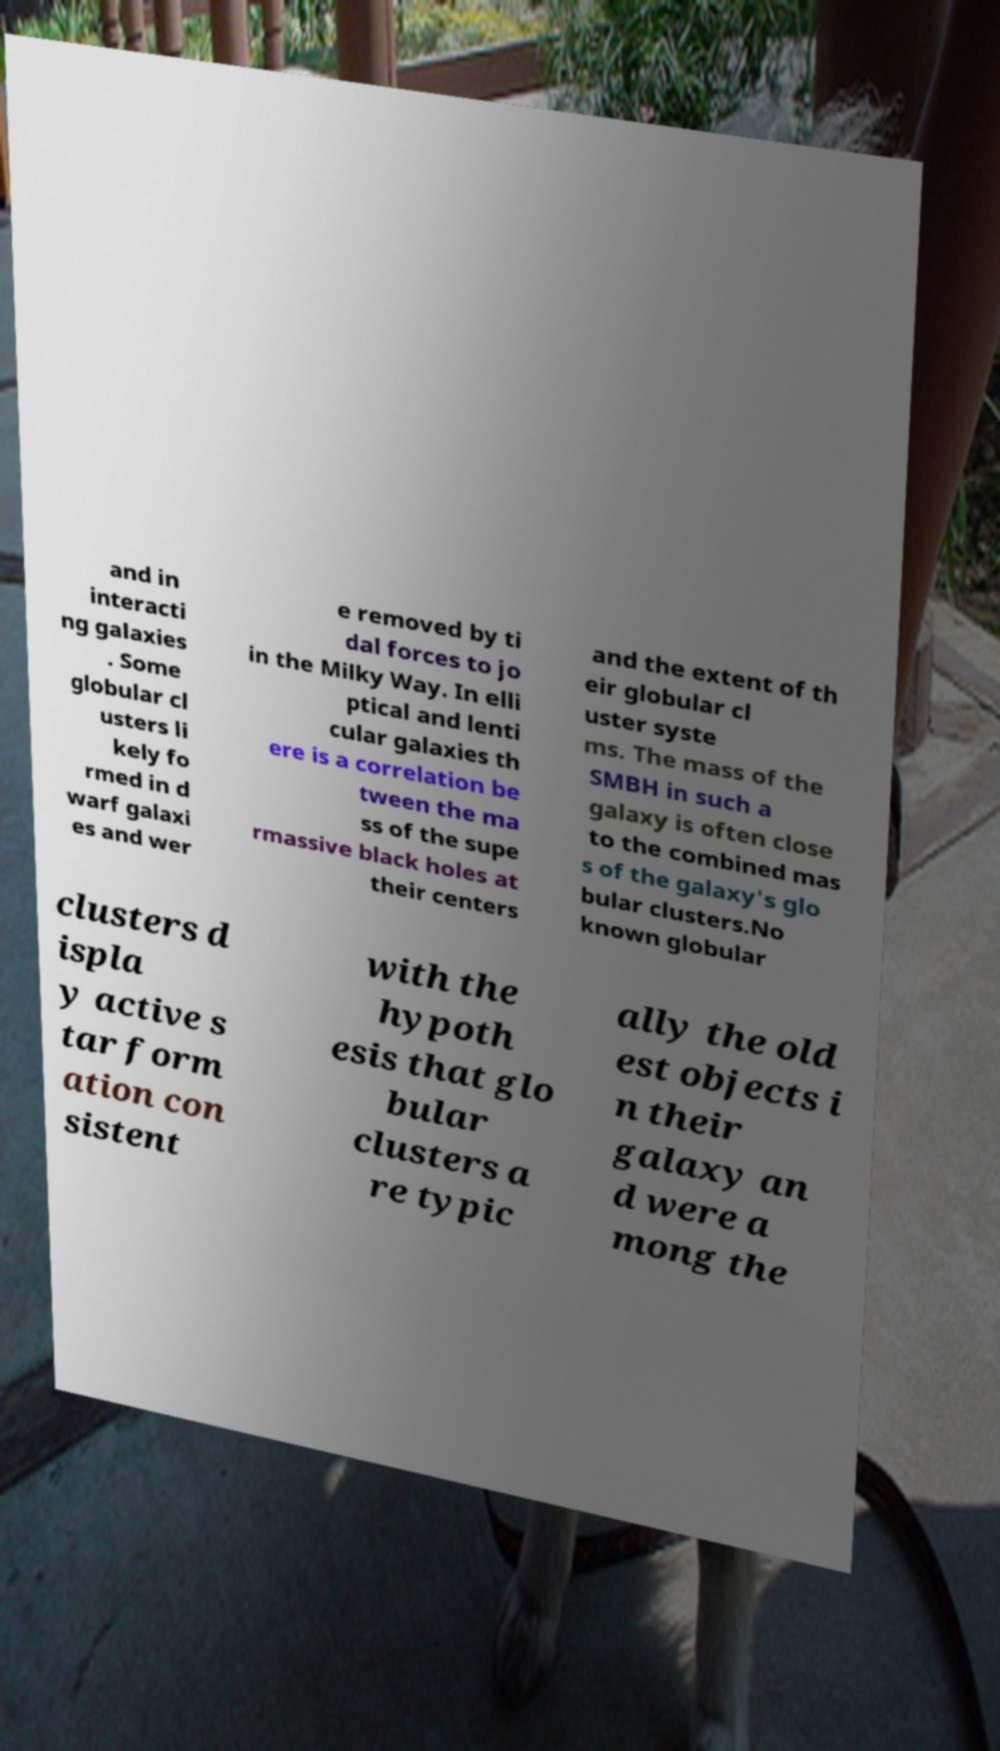What messages or text are displayed in this image? I need them in a readable, typed format. and in interacti ng galaxies . Some globular cl usters li kely fo rmed in d warf galaxi es and wer e removed by ti dal forces to jo in the Milky Way. In elli ptical and lenti cular galaxies th ere is a correlation be tween the ma ss of the supe rmassive black holes at their centers and the extent of th eir globular cl uster syste ms. The mass of the SMBH in such a galaxy is often close to the combined mas s of the galaxy's glo bular clusters.No known globular clusters d ispla y active s tar form ation con sistent with the hypoth esis that glo bular clusters a re typic ally the old est objects i n their galaxy an d were a mong the 